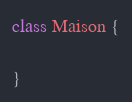<code> <loc_0><loc_0><loc_500><loc_500><_JavaScript_>class Maison {

}</code> 